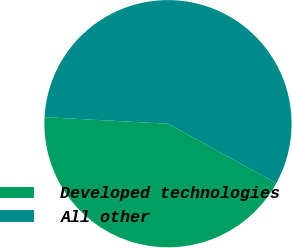Convert chart. <chart><loc_0><loc_0><loc_500><loc_500><pie_chart><fcel>Developed technologies<fcel>All other<nl><fcel>42.86%<fcel>57.14%<nl></chart> 